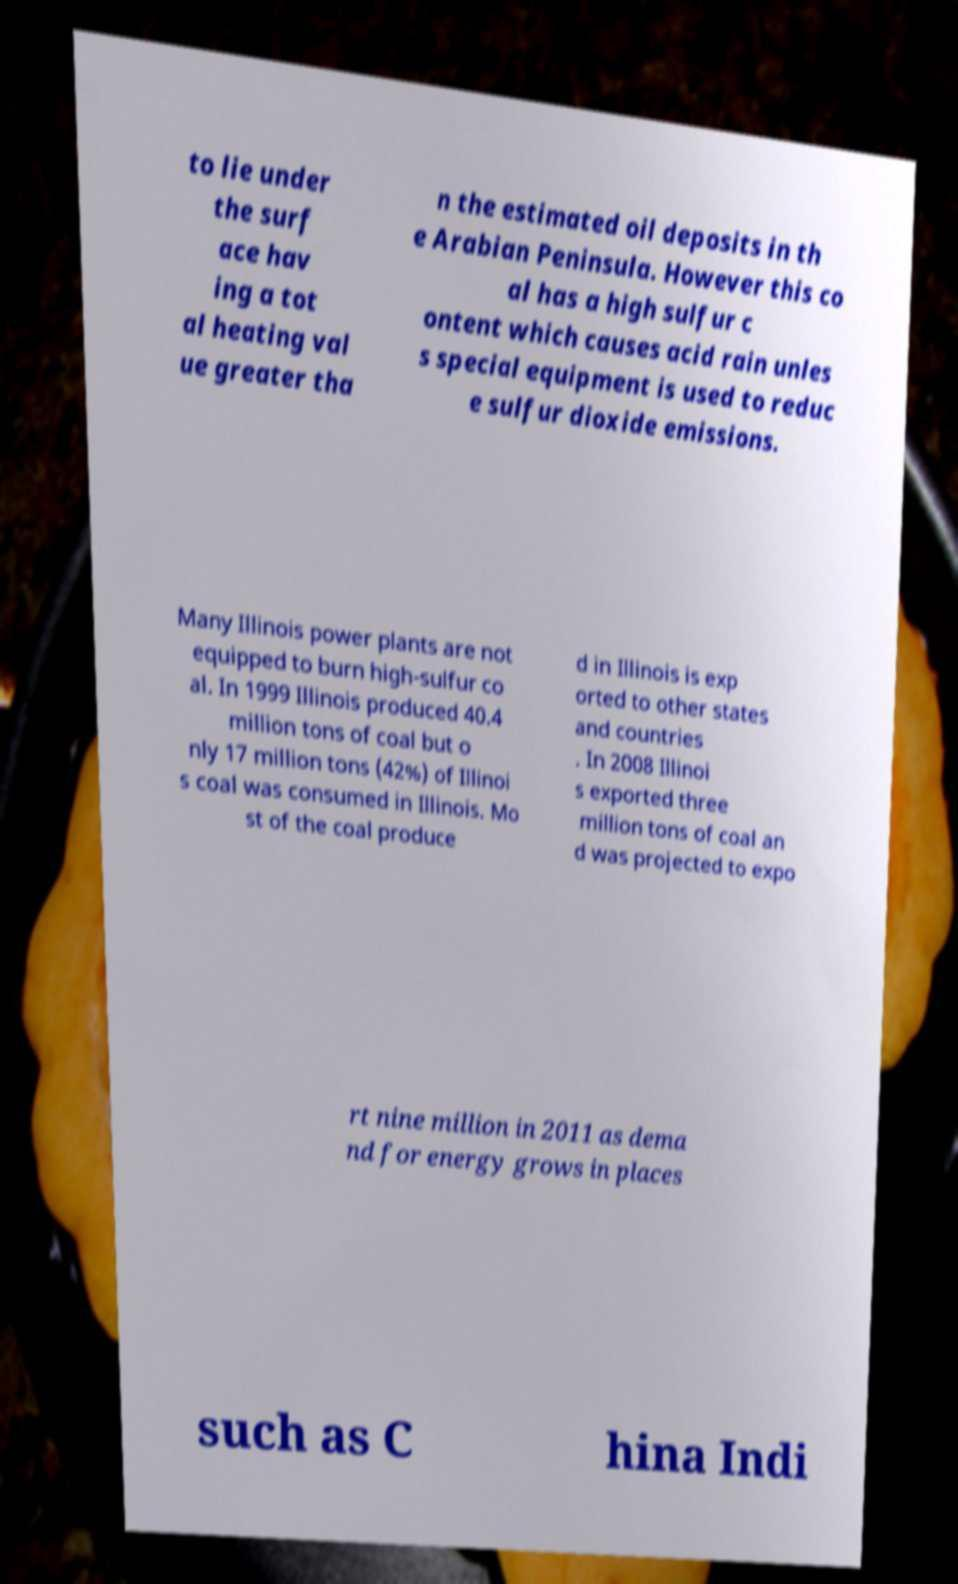Please identify and transcribe the text found in this image. to lie under the surf ace hav ing a tot al heating val ue greater tha n the estimated oil deposits in th e Arabian Peninsula. However this co al has a high sulfur c ontent which causes acid rain unles s special equipment is used to reduc e sulfur dioxide emissions. Many Illinois power plants are not equipped to burn high-sulfur co al. In 1999 Illinois produced 40.4 million tons of coal but o nly 17 million tons (42%) of Illinoi s coal was consumed in Illinois. Mo st of the coal produce d in Illinois is exp orted to other states and countries . In 2008 Illinoi s exported three million tons of coal an d was projected to expo rt nine million in 2011 as dema nd for energy grows in places such as C hina Indi 